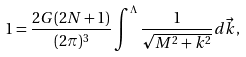<formula> <loc_0><loc_0><loc_500><loc_500>1 = \frac { 2 G ( 2 N + 1 ) } { ( 2 \pi ) ^ { 3 } } \int ^ { \Lambda } \frac { 1 } { \sqrt { M ^ { 2 } + k ^ { 2 } } } d \vec { k } ,</formula> 